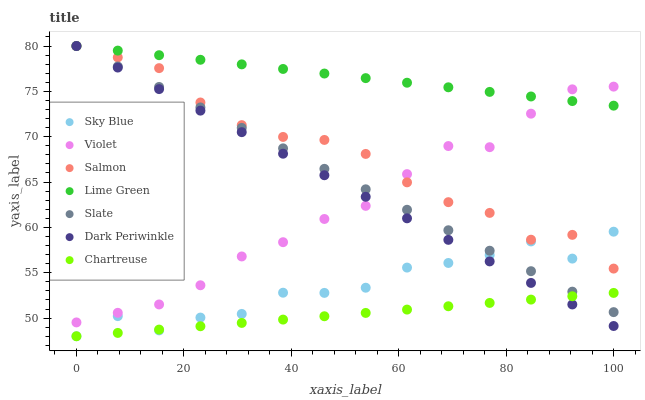Does Chartreuse have the minimum area under the curve?
Answer yes or no. Yes. Does Lime Green have the maximum area under the curve?
Answer yes or no. Yes. Does Salmon have the minimum area under the curve?
Answer yes or no. No. Does Salmon have the maximum area under the curve?
Answer yes or no. No. Is Chartreuse the smoothest?
Answer yes or no. Yes. Is Sky Blue the roughest?
Answer yes or no. Yes. Is Salmon the smoothest?
Answer yes or no. No. Is Salmon the roughest?
Answer yes or no. No. Does Chartreuse have the lowest value?
Answer yes or no. Yes. Does Salmon have the lowest value?
Answer yes or no. No. Does Dark Periwinkle have the highest value?
Answer yes or no. Yes. Does Chartreuse have the highest value?
Answer yes or no. No. Is Chartreuse less than Violet?
Answer yes or no. Yes. Is Violet greater than Sky Blue?
Answer yes or no. Yes. Does Lime Green intersect Dark Periwinkle?
Answer yes or no. Yes. Is Lime Green less than Dark Periwinkle?
Answer yes or no. No. Is Lime Green greater than Dark Periwinkle?
Answer yes or no. No. Does Chartreuse intersect Violet?
Answer yes or no. No. 